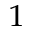<formula> <loc_0><loc_0><loc_500><loc_500>^ { 1 }</formula> 